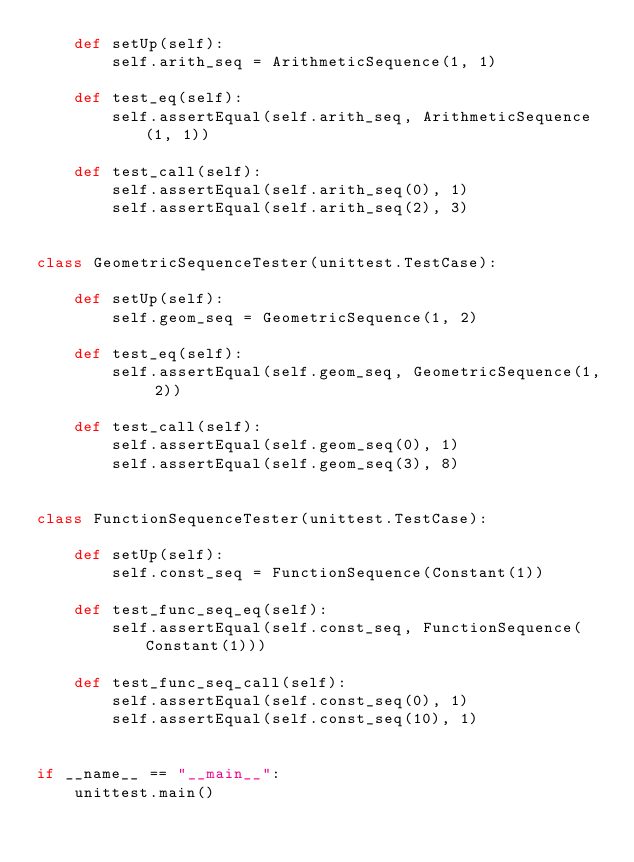<code> <loc_0><loc_0><loc_500><loc_500><_Python_>    def setUp(self):
        self.arith_seq = ArithmeticSequence(1, 1)

    def test_eq(self):
        self.assertEqual(self.arith_seq, ArithmeticSequence(1, 1))

    def test_call(self):
        self.assertEqual(self.arith_seq(0), 1)
        self.assertEqual(self.arith_seq(2), 3)


class GeometricSequenceTester(unittest.TestCase):

    def setUp(self):
        self.geom_seq = GeometricSequence(1, 2)

    def test_eq(self):
        self.assertEqual(self.geom_seq, GeometricSequence(1, 2))

    def test_call(self):
        self.assertEqual(self.geom_seq(0), 1)
        self.assertEqual(self.geom_seq(3), 8)


class FunctionSequenceTester(unittest.TestCase):

    def setUp(self):
        self.const_seq = FunctionSequence(Constant(1))

    def test_func_seq_eq(self):
        self.assertEqual(self.const_seq, FunctionSequence(Constant(1)))

    def test_func_seq_call(self):
        self.assertEqual(self.const_seq(0), 1)
        self.assertEqual(self.const_seq(10), 1)


if __name__ == "__main__":
    unittest.main()
</code> 